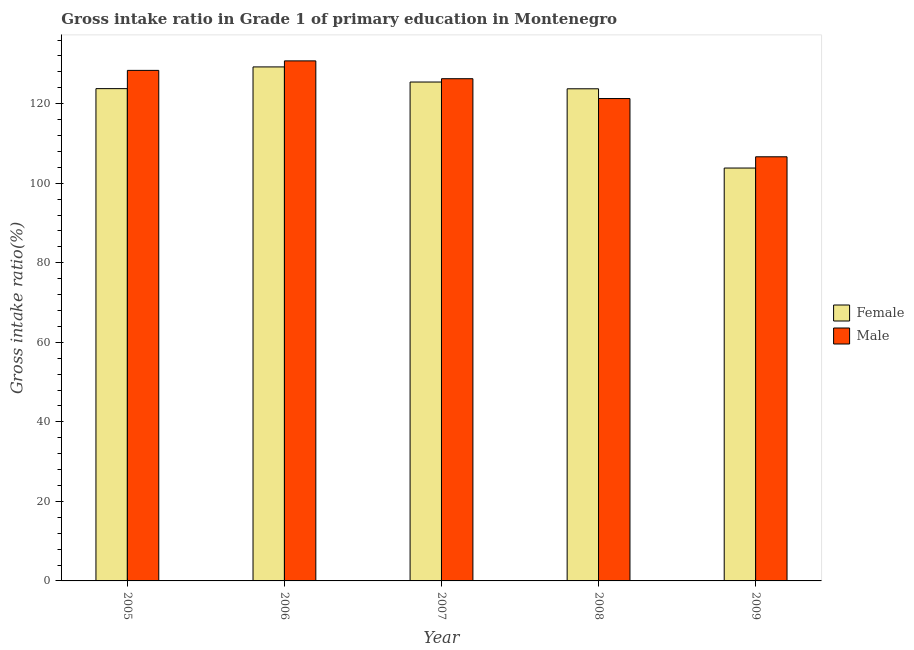How many groups of bars are there?
Offer a terse response. 5. Are the number of bars per tick equal to the number of legend labels?
Provide a succinct answer. Yes. Are the number of bars on each tick of the X-axis equal?
Your answer should be compact. Yes. How many bars are there on the 1st tick from the right?
Make the answer very short. 2. What is the label of the 4th group of bars from the left?
Provide a short and direct response. 2008. In how many cases, is the number of bars for a given year not equal to the number of legend labels?
Make the answer very short. 0. What is the gross intake ratio(male) in 2005?
Ensure brevity in your answer.  128.38. Across all years, what is the maximum gross intake ratio(male)?
Keep it short and to the point. 130.77. Across all years, what is the minimum gross intake ratio(female)?
Your response must be concise. 103.82. What is the total gross intake ratio(male) in the graph?
Offer a terse response. 613.37. What is the difference between the gross intake ratio(male) in 2007 and that in 2008?
Give a very brief answer. 4.99. What is the difference between the gross intake ratio(male) in 2005 and the gross intake ratio(female) in 2006?
Keep it short and to the point. -2.39. What is the average gross intake ratio(female) per year?
Keep it short and to the point. 121.21. In how many years, is the gross intake ratio(male) greater than 32 %?
Provide a succinct answer. 5. What is the ratio of the gross intake ratio(male) in 2006 to that in 2008?
Provide a short and direct response. 1.08. Is the gross intake ratio(male) in 2006 less than that in 2008?
Your answer should be compact. No. What is the difference between the highest and the second highest gross intake ratio(male)?
Offer a very short reply. 2.39. What is the difference between the highest and the lowest gross intake ratio(female)?
Make the answer very short. 25.42. In how many years, is the gross intake ratio(female) greater than the average gross intake ratio(female) taken over all years?
Make the answer very short. 4. Is the sum of the gross intake ratio(female) in 2005 and 2007 greater than the maximum gross intake ratio(male) across all years?
Your answer should be compact. Yes. What does the 1st bar from the left in 2005 represents?
Offer a very short reply. Female. How many bars are there?
Provide a short and direct response. 10. Are all the bars in the graph horizontal?
Your answer should be very brief. No. How many years are there in the graph?
Your answer should be very brief. 5. What is the difference between two consecutive major ticks on the Y-axis?
Your answer should be very brief. 20. Are the values on the major ticks of Y-axis written in scientific E-notation?
Offer a terse response. No. Does the graph contain grids?
Your answer should be compact. No. Where does the legend appear in the graph?
Give a very brief answer. Center right. How many legend labels are there?
Ensure brevity in your answer.  2. How are the legend labels stacked?
Provide a succinct answer. Vertical. What is the title of the graph?
Ensure brevity in your answer.  Gross intake ratio in Grade 1 of primary education in Montenegro. Does "Drinking water services" appear as one of the legend labels in the graph?
Make the answer very short. No. What is the label or title of the Y-axis?
Ensure brevity in your answer.  Gross intake ratio(%). What is the Gross intake ratio(%) in Female in 2005?
Your answer should be very brief. 123.79. What is the Gross intake ratio(%) in Male in 2005?
Provide a short and direct response. 128.38. What is the Gross intake ratio(%) in Female in 2006?
Offer a very short reply. 129.25. What is the Gross intake ratio(%) of Male in 2006?
Give a very brief answer. 130.77. What is the Gross intake ratio(%) in Female in 2007?
Give a very brief answer. 125.45. What is the Gross intake ratio(%) of Male in 2007?
Give a very brief answer. 126.28. What is the Gross intake ratio(%) of Female in 2008?
Ensure brevity in your answer.  123.75. What is the Gross intake ratio(%) in Male in 2008?
Give a very brief answer. 121.29. What is the Gross intake ratio(%) of Female in 2009?
Ensure brevity in your answer.  103.82. What is the Gross intake ratio(%) in Male in 2009?
Offer a very short reply. 106.65. Across all years, what is the maximum Gross intake ratio(%) in Female?
Ensure brevity in your answer.  129.25. Across all years, what is the maximum Gross intake ratio(%) of Male?
Offer a terse response. 130.77. Across all years, what is the minimum Gross intake ratio(%) of Female?
Your response must be concise. 103.82. Across all years, what is the minimum Gross intake ratio(%) of Male?
Your answer should be very brief. 106.65. What is the total Gross intake ratio(%) of Female in the graph?
Offer a terse response. 606.05. What is the total Gross intake ratio(%) of Male in the graph?
Your response must be concise. 613.37. What is the difference between the Gross intake ratio(%) in Female in 2005 and that in 2006?
Your answer should be compact. -5.46. What is the difference between the Gross intake ratio(%) in Male in 2005 and that in 2006?
Provide a succinct answer. -2.39. What is the difference between the Gross intake ratio(%) of Female in 2005 and that in 2007?
Make the answer very short. -1.66. What is the difference between the Gross intake ratio(%) in Male in 2005 and that in 2007?
Ensure brevity in your answer.  2.09. What is the difference between the Gross intake ratio(%) of Female in 2005 and that in 2008?
Provide a short and direct response. 0.04. What is the difference between the Gross intake ratio(%) in Male in 2005 and that in 2008?
Provide a succinct answer. 7.08. What is the difference between the Gross intake ratio(%) of Female in 2005 and that in 2009?
Provide a short and direct response. 19.97. What is the difference between the Gross intake ratio(%) of Male in 2005 and that in 2009?
Your answer should be very brief. 21.73. What is the difference between the Gross intake ratio(%) in Female in 2006 and that in 2007?
Ensure brevity in your answer.  3.8. What is the difference between the Gross intake ratio(%) of Male in 2006 and that in 2007?
Ensure brevity in your answer.  4.48. What is the difference between the Gross intake ratio(%) of Female in 2006 and that in 2008?
Make the answer very short. 5.5. What is the difference between the Gross intake ratio(%) of Male in 2006 and that in 2008?
Give a very brief answer. 9.47. What is the difference between the Gross intake ratio(%) of Female in 2006 and that in 2009?
Offer a terse response. 25.42. What is the difference between the Gross intake ratio(%) of Male in 2006 and that in 2009?
Make the answer very short. 24.12. What is the difference between the Gross intake ratio(%) of Female in 2007 and that in 2008?
Make the answer very short. 1.7. What is the difference between the Gross intake ratio(%) in Male in 2007 and that in 2008?
Offer a terse response. 4.99. What is the difference between the Gross intake ratio(%) of Female in 2007 and that in 2009?
Provide a short and direct response. 21.63. What is the difference between the Gross intake ratio(%) in Male in 2007 and that in 2009?
Give a very brief answer. 19.63. What is the difference between the Gross intake ratio(%) of Female in 2008 and that in 2009?
Your response must be concise. 19.93. What is the difference between the Gross intake ratio(%) of Male in 2008 and that in 2009?
Ensure brevity in your answer.  14.64. What is the difference between the Gross intake ratio(%) of Female in 2005 and the Gross intake ratio(%) of Male in 2006?
Provide a succinct answer. -6.98. What is the difference between the Gross intake ratio(%) in Female in 2005 and the Gross intake ratio(%) in Male in 2007?
Offer a very short reply. -2.5. What is the difference between the Gross intake ratio(%) of Female in 2005 and the Gross intake ratio(%) of Male in 2008?
Provide a succinct answer. 2.5. What is the difference between the Gross intake ratio(%) of Female in 2005 and the Gross intake ratio(%) of Male in 2009?
Provide a short and direct response. 17.14. What is the difference between the Gross intake ratio(%) of Female in 2006 and the Gross intake ratio(%) of Male in 2007?
Make the answer very short. 2.96. What is the difference between the Gross intake ratio(%) in Female in 2006 and the Gross intake ratio(%) in Male in 2008?
Provide a short and direct response. 7.95. What is the difference between the Gross intake ratio(%) in Female in 2006 and the Gross intake ratio(%) in Male in 2009?
Your answer should be very brief. 22.6. What is the difference between the Gross intake ratio(%) of Female in 2007 and the Gross intake ratio(%) of Male in 2008?
Your answer should be compact. 4.16. What is the difference between the Gross intake ratio(%) in Female in 2007 and the Gross intake ratio(%) in Male in 2009?
Provide a short and direct response. 18.8. What is the difference between the Gross intake ratio(%) in Female in 2008 and the Gross intake ratio(%) in Male in 2009?
Keep it short and to the point. 17.1. What is the average Gross intake ratio(%) in Female per year?
Your answer should be compact. 121.21. What is the average Gross intake ratio(%) in Male per year?
Make the answer very short. 122.67. In the year 2005, what is the difference between the Gross intake ratio(%) in Female and Gross intake ratio(%) in Male?
Your response must be concise. -4.59. In the year 2006, what is the difference between the Gross intake ratio(%) of Female and Gross intake ratio(%) of Male?
Make the answer very short. -1.52. In the year 2007, what is the difference between the Gross intake ratio(%) of Female and Gross intake ratio(%) of Male?
Provide a short and direct response. -0.83. In the year 2008, what is the difference between the Gross intake ratio(%) in Female and Gross intake ratio(%) in Male?
Keep it short and to the point. 2.45. In the year 2009, what is the difference between the Gross intake ratio(%) in Female and Gross intake ratio(%) in Male?
Keep it short and to the point. -2.83. What is the ratio of the Gross intake ratio(%) in Female in 2005 to that in 2006?
Your answer should be compact. 0.96. What is the ratio of the Gross intake ratio(%) in Male in 2005 to that in 2006?
Keep it short and to the point. 0.98. What is the ratio of the Gross intake ratio(%) of Female in 2005 to that in 2007?
Keep it short and to the point. 0.99. What is the ratio of the Gross intake ratio(%) of Male in 2005 to that in 2007?
Keep it short and to the point. 1.02. What is the ratio of the Gross intake ratio(%) of Male in 2005 to that in 2008?
Keep it short and to the point. 1.06. What is the ratio of the Gross intake ratio(%) of Female in 2005 to that in 2009?
Keep it short and to the point. 1.19. What is the ratio of the Gross intake ratio(%) of Male in 2005 to that in 2009?
Your response must be concise. 1.2. What is the ratio of the Gross intake ratio(%) in Female in 2006 to that in 2007?
Give a very brief answer. 1.03. What is the ratio of the Gross intake ratio(%) of Male in 2006 to that in 2007?
Provide a short and direct response. 1.04. What is the ratio of the Gross intake ratio(%) in Female in 2006 to that in 2008?
Offer a very short reply. 1.04. What is the ratio of the Gross intake ratio(%) of Male in 2006 to that in 2008?
Keep it short and to the point. 1.08. What is the ratio of the Gross intake ratio(%) in Female in 2006 to that in 2009?
Provide a succinct answer. 1.24. What is the ratio of the Gross intake ratio(%) of Male in 2006 to that in 2009?
Provide a short and direct response. 1.23. What is the ratio of the Gross intake ratio(%) in Female in 2007 to that in 2008?
Offer a terse response. 1.01. What is the ratio of the Gross intake ratio(%) of Male in 2007 to that in 2008?
Provide a short and direct response. 1.04. What is the ratio of the Gross intake ratio(%) in Female in 2007 to that in 2009?
Your response must be concise. 1.21. What is the ratio of the Gross intake ratio(%) of Male in 2007 to that in 2009?
Your response must be concise. 1.18. What is the ratio of the Gross intake ratio(%) in Female in 2008 to that in 2009?
Provide a succinct answer. 1.19. What is the ratio of the Gross intake ratio(%) in Male in 2008 to that in 2009?
Give a very brief answer. 1.14. What is the difference between the highest and the second highest Gross intake ratio(%) in Female?
Provide a short and direct response. 3.8. What is the difference between the highest and the second highest Gross intake ratio(%) in Male?
Your answer should be very brief. 2.39. What is the difference between the highest and the lowest Gross intake ratio(%) in Female?
Make the answer very short. 25.42. What is the difference between the highest and the lowest Gross intake ratio(%) in Male?
Give a very brief answer. 24.12. 